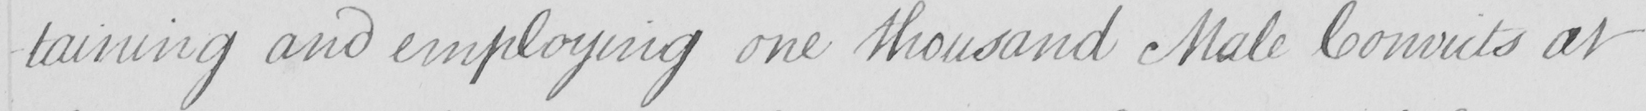What does this handwritten line say? -taining and employing one thousand Male Convicts at 